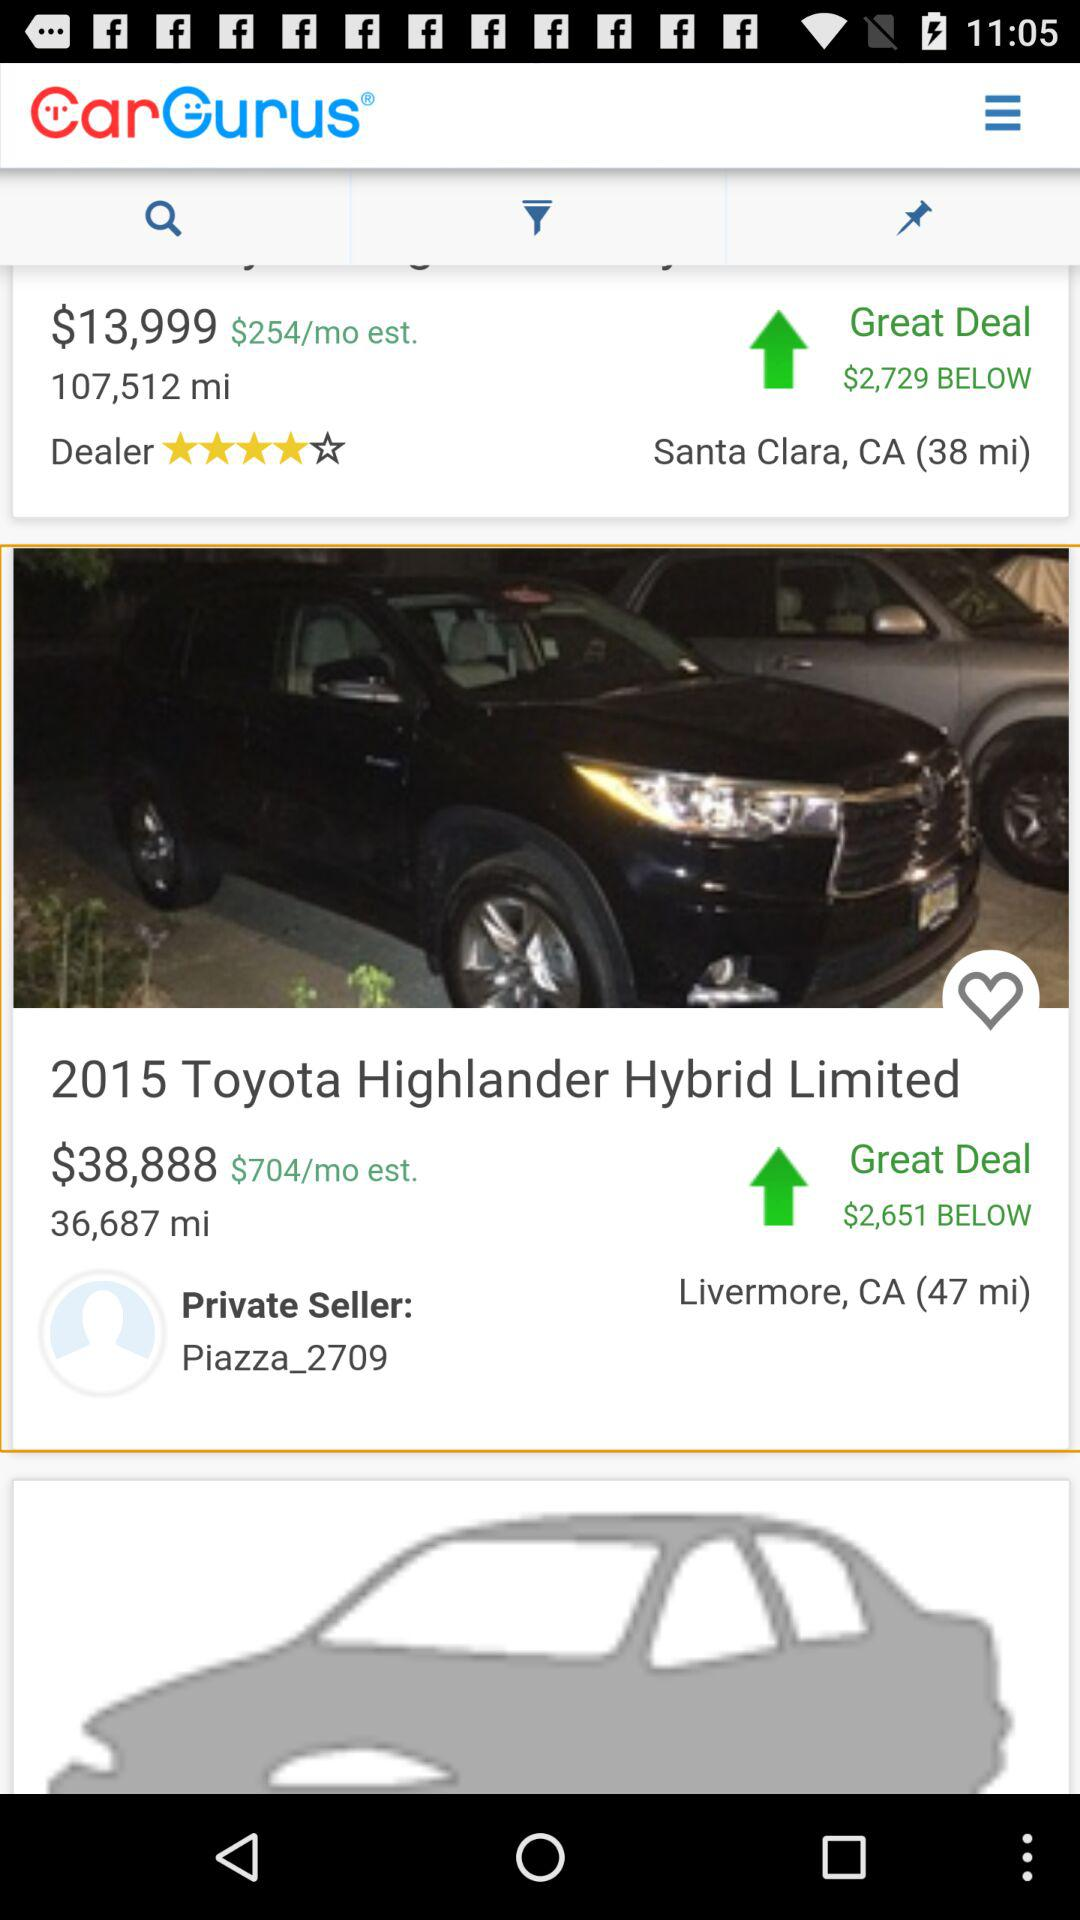How many kilo metres are shown on the screen?
When the provided information is insufficient, respond with <no answer>. <no answer> 